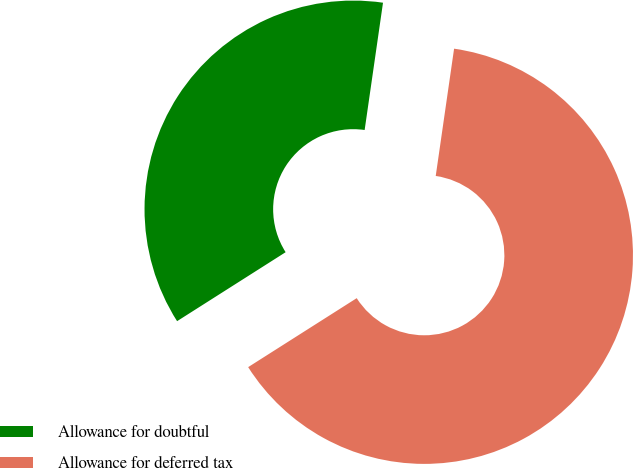Convert chart to OTSL. <chart><loc_0><loc_0><loc_500><loc_500><pie_chart><fcel>Allowance for doubtful<fcel>Allowance for deferred tax<nl><fcel>36.29%<fcel>63.71%<nl></chart> 